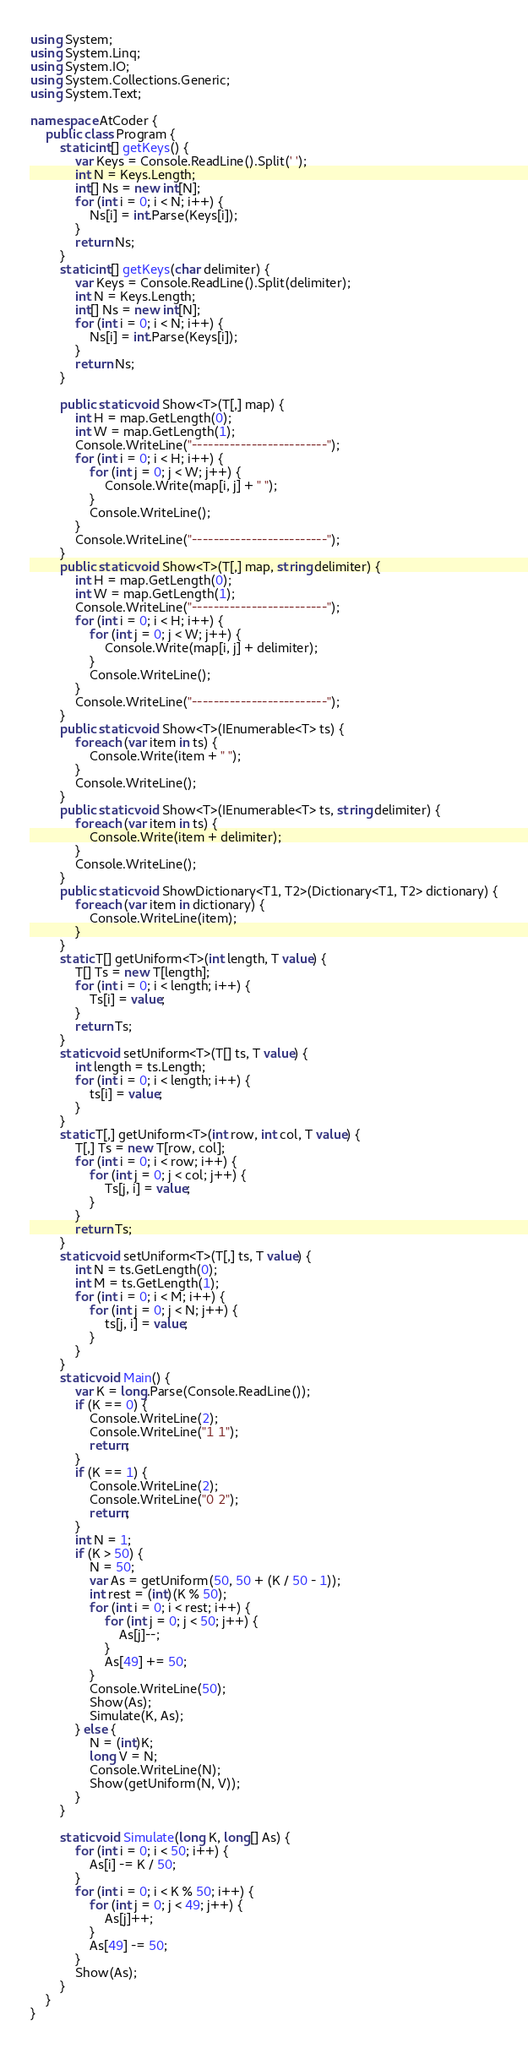Convert code to text. <code><loc_0><loc_0><loc_500><loc_500><_C#_>using System;
using System.Linq;
using System.IO;
using System.Collections.Generic;
using System.Text;

namespace AtCoder {
    public class Program {
        static int[] getKeys() {
            var Keys = Console.ReadLine().Split(' ');
            int N = Keys.Length;
            int[] Ns = new int[N];
            for (int i = 0; i < N; i++) {
                Ns[i] = int.Parse(Keys[i]);
            }
            return Ns;
        }
        static int[] getKeys(char delimiter) {
            var Keys = Console.ReadLine().Split(delimiter);
            int N = Keys.Length;
            int[] Ns = new int[N];
            for (int i = 0; i < N; i++) {
                Ns[i] = int.Parse(Keys[i]);
            }
            return Ns;
        }

        public static void Show<T>(T[,] map) {
            int H = map.GetLength(0);
            int W = map.GetLength(1);
            Console.WriteLine("-------------------------");
            for (int i = 0; i < H; i++) {
                for (int j = 0; j < W; j++) {
                    Console.Write(map[i, j] + " ");
                }
                Console.WriteLine();
            }
            Console.WriteLine("-------------------------");
        }
        public static void Show<T>(T[,] map, string delimiter) {
            int H = map.GetLength(0);
            int W = map.GetLength(1);
            Console.WriteLine("-------------------------");
            for (int i = 0; i < H; i++) {
                for (int j = 0; j < W; j++) {
                    Console.Write(map[i, j] + delimiter);
                }
                Console.WriteLine();
            }
            Console.WriteLine("-------------------------");
        }
        public static void Show<T>(IEnumerable<T> ts) {
            foreach (var item in ts) {
                Console.Write(item + " ");
            }
            Console.WriteLine();
        }
        public static void Show<T>(IEnumerable<T> ts, string delimiter) {
            foreach (var item in ts) {
                Console.Write(item + delimiter);
            }
            Console.WriteLine();
        }
        public static void ShowDictionary<T1, T2>(Dictionary<T1, T2> dictionary) {
            foreach (var item in dictionary) {
                Console.WriteLine(item);
            }
        }
        static T[] getUniform<T>(int length, T value) {
            T[] Ts = new T[length];
            for (int i = 0; i < length; i++) {
                Ts[i] = value;
            }
            return Ts;
        }
        static void setUniform<T>(T[] ts, T value) {
            int length = ts.Length;
            for (int i = 0; i < length; i++) {
                ts[i] = value;
            }
        }
        static T[,] getUniform<T>(int row, int col, T value) {
            T[,] Ts = new T[row, col];
            for (int i = 0; i < row; i++) {
                for (int j = 0; j < col; j++) {
                    Ts[j, i] = value;
                }
            }
            return Ts;
        }
        static void setUniform<T>(T[,] ts, T value) {
            int N = ts.GetLength(0);
            int M = ts.GetLength(1);
            for (int i = 0; i < M; i++) {
                for (int j = 0; j < N; j++) {
                    ts[j, i] = value;
                }
            }
        }
        static void Main() {
            var K = long.Parse(Console.ReadLine());
            if (K == 0) {
                Console.WriteLine(2);
                Console.WriteLine("1 1");
                return;
            }
            if (K == 1) {
                Console.WriteLine(2);
                Console.WriteLine("0 2");
                return;
            }
            int N = 1;
            if (K > 50) {
                N = 50;
                var As = getUniform(50, 50 + (K / 50 - 1));
                int rest = (int)(K % 50);
                for (int i = 0; i < rest; i++) {
                    for (int j = 0; j < 50; j++) {
                        As[j]--;
                    }
                    As[49] += 50;
                }
                Console.WriteLine(50);
                Show(As);
                Simulate(K, As);
            } else {
                N = (int)K;
                long V = N;
                Console.WriteLine(N);
                Show(getUniform(N, V));
            }
        }

        static void Simulate(long K, long[] As) {
            for (int i = 0; i < 50; i++) {
                As[i] -= K / 50;
            }
            for (int i = 0; i < K % 50; i++) {
                for (int j = 0; j < 49; j++) {
                    As[j]++;
                }
                As[49] -= 50;
            }
            Show(As);
        }
    }
}</code> 